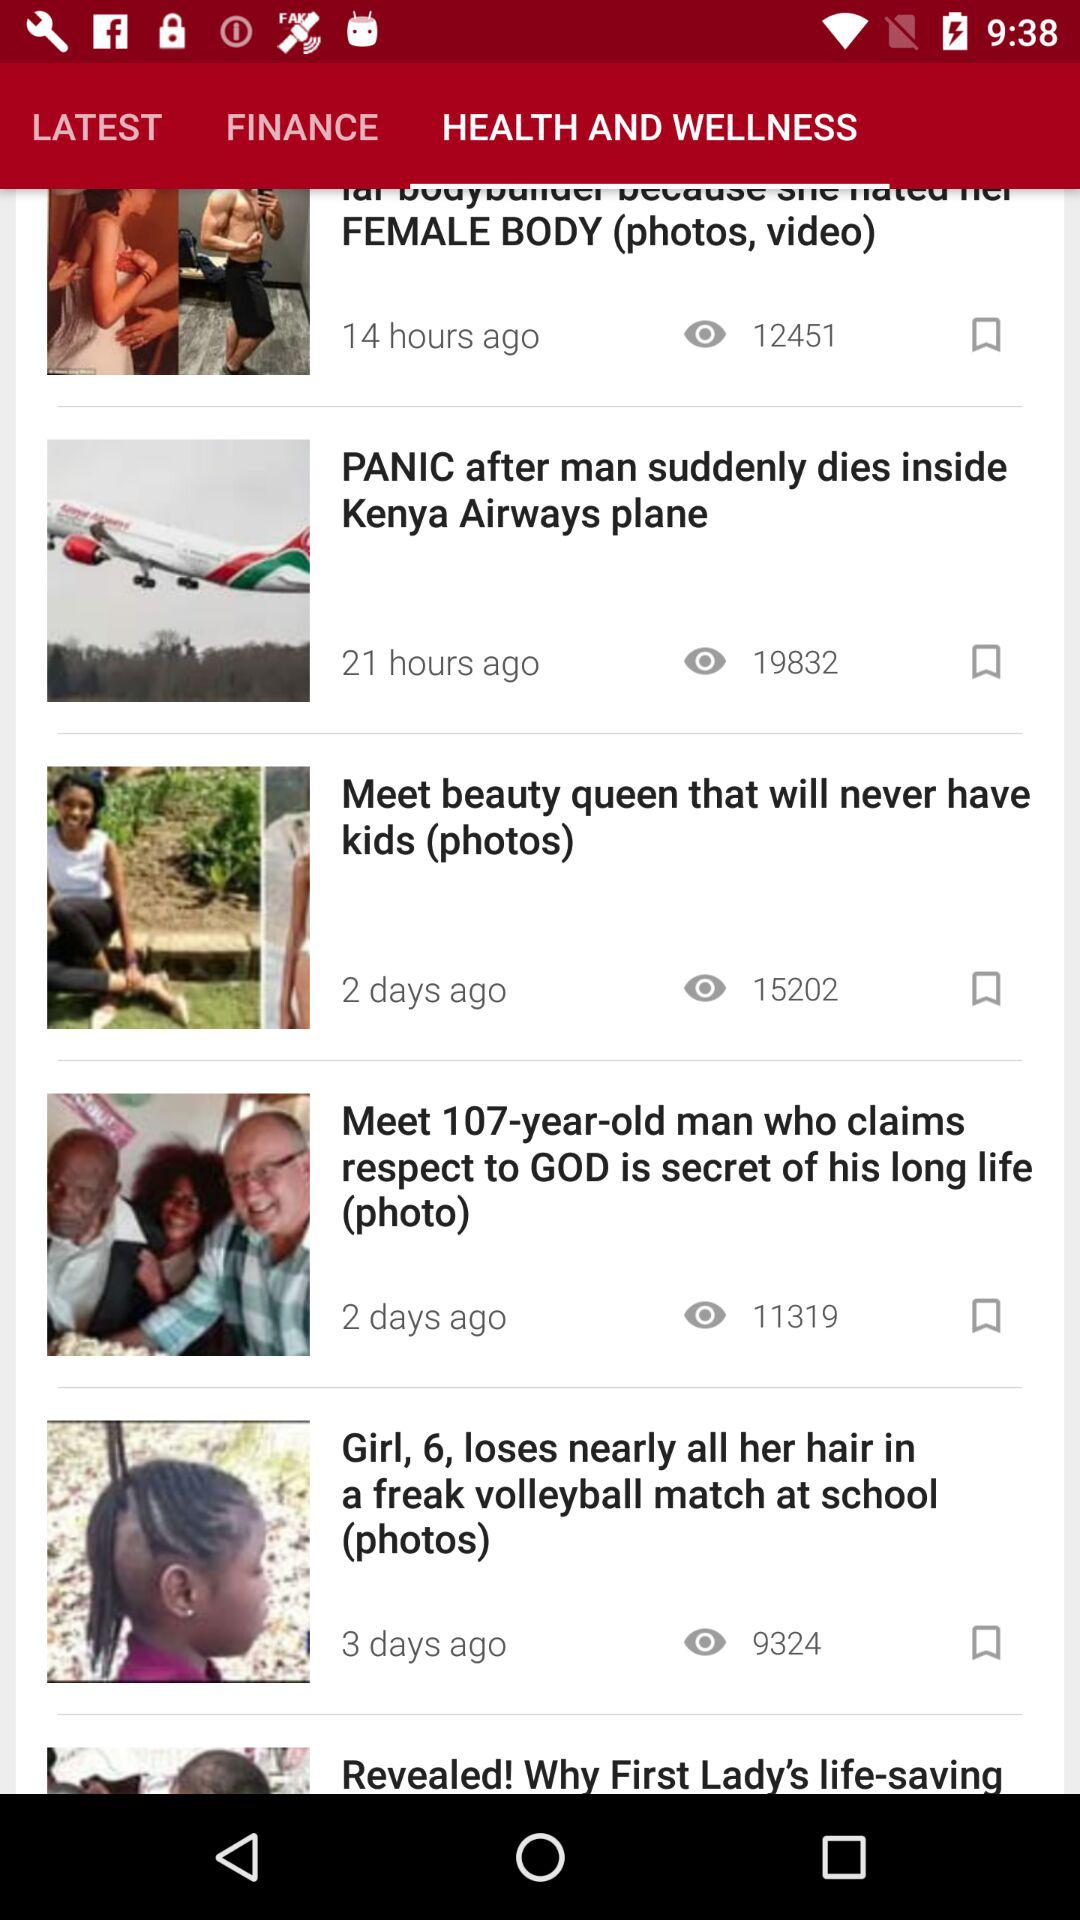How many hours ago was the latest article published?
Answer the question using a single word or phrase. 14 